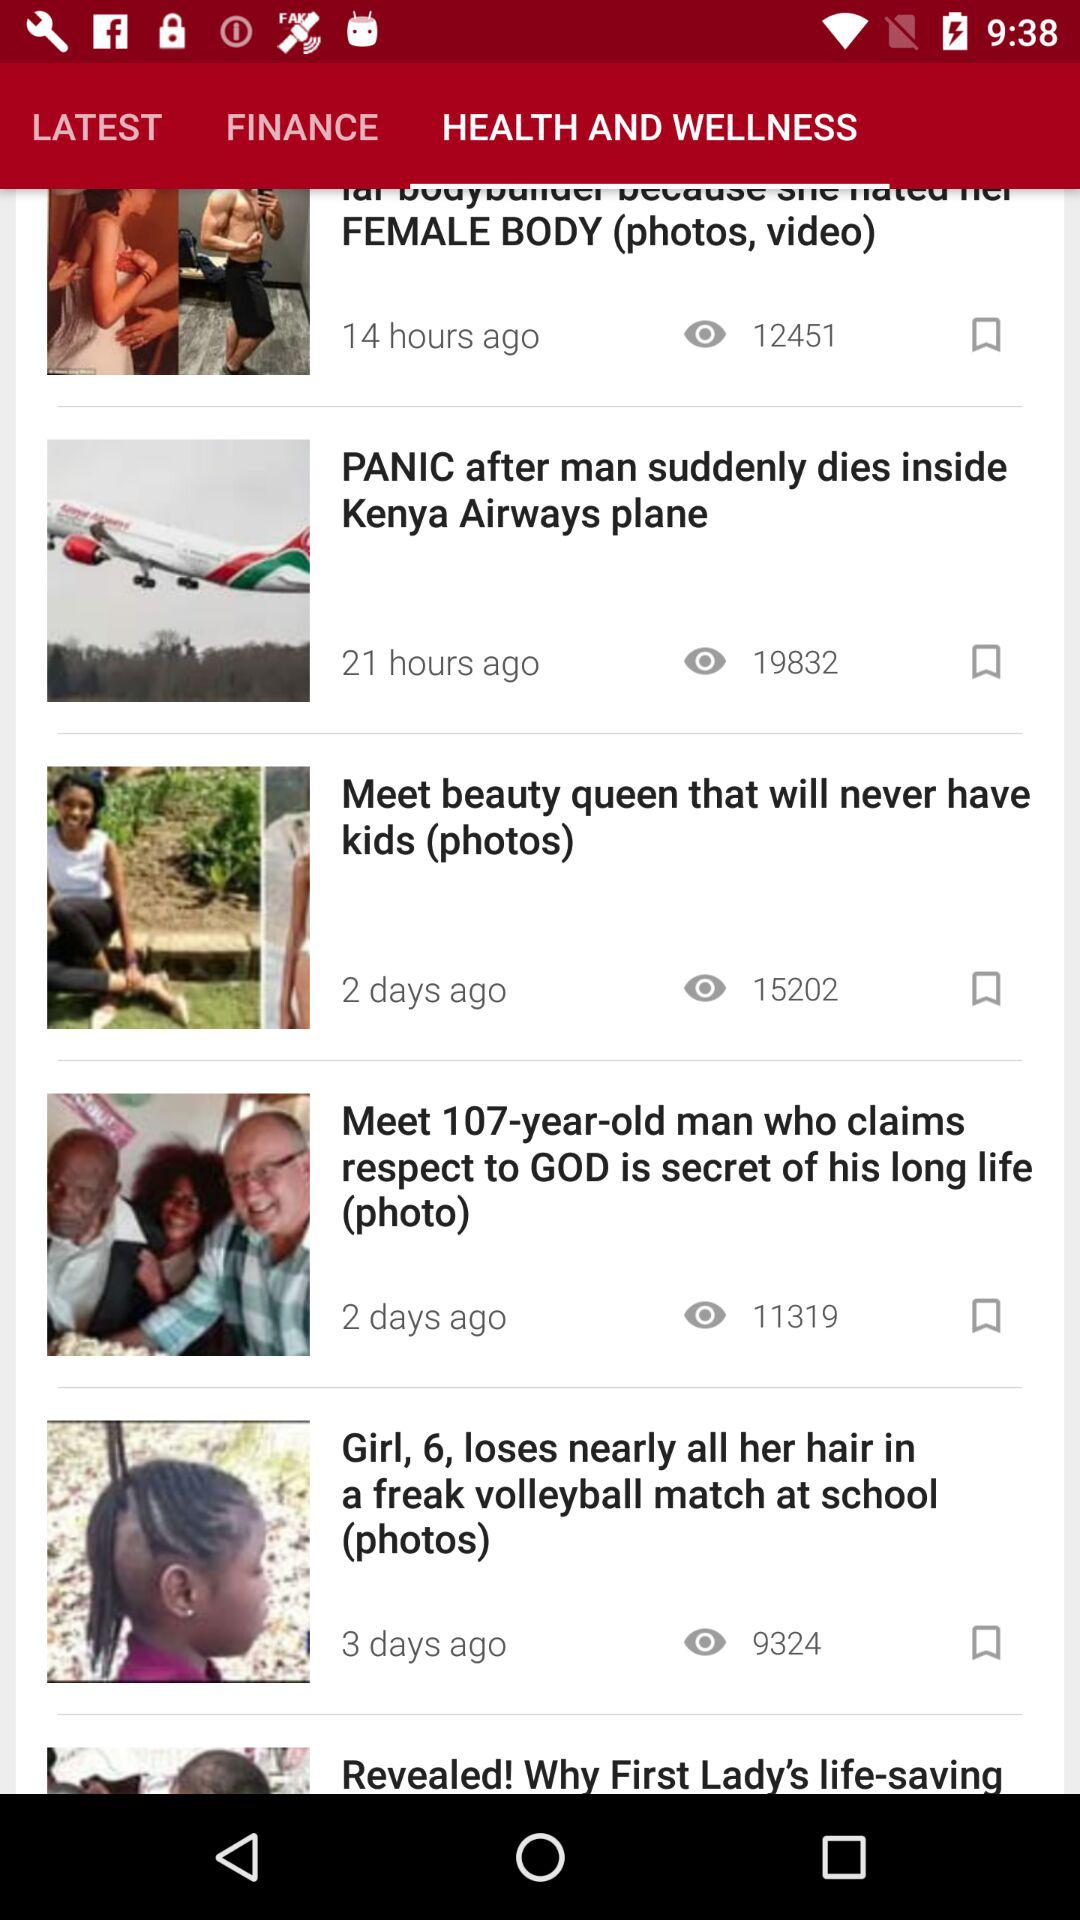How many hours ago was the latest article published?
Answer the question using a single word or phrase. 14 